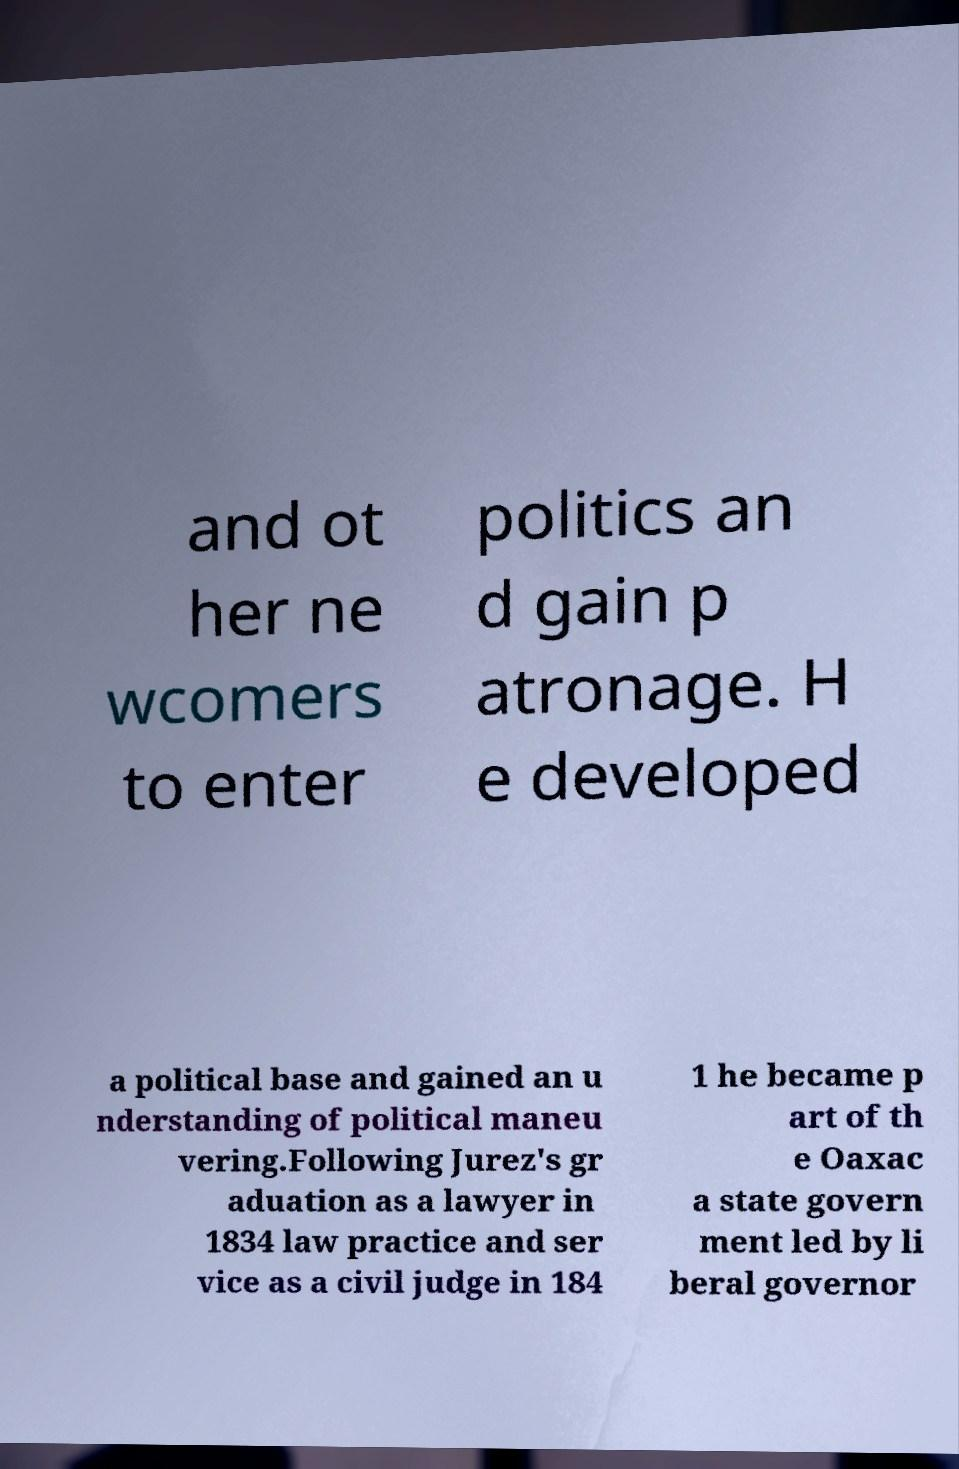Please read and relay the text visible in this image. What does it say? and ot her ne wcomers to enter politics an d gain p atronage. H e developed a political base and gained an u nderstanding of political maneu vering.Following Jurez's gr aduation as a lawyer in 1834 law practice and ser vice as a civil judge in 184 1 he became p art of th e Oaxac a state govern ment led by li beral governor 